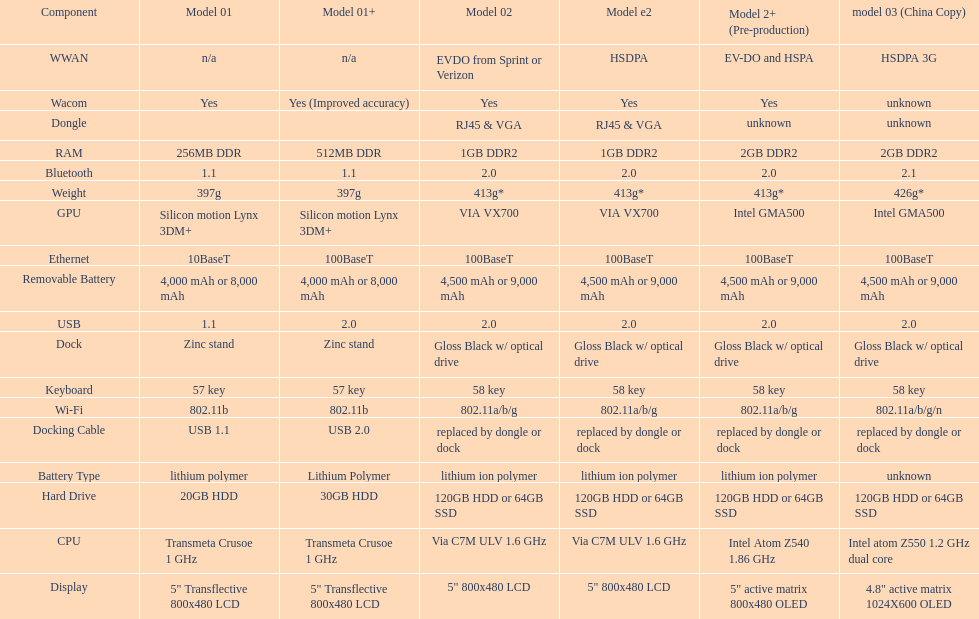How much more weight does the model 3 have over model 1? 29g. Can you give me this table as a dict? {'header': ['Component', 'Model 01', 'Model 01+', 'Model 02', 'Model e2', 'Model 2+ (Pre-production)', 'model 03 (China Copy)'], 'rows': [['WWAN', 'n/a', 'n/a', 'EVDO from Sprint or Verizon', 'HSDPA', 'EV-DO and HSPA', 'HSDPA 3G'], ['Wacom', 'Yes', 'Yes (Improved accuracy)', 'Yes', 'Yes', 'Yes', 'unknown'], ['Dongle', '', '', 'RJ45 & VGA', 'RJ45 & VGA', 'unknown', 'unknown'], ['RAM', '256MB DDR', '512MB DDR', '1GB DDR2', '1GB DDR2', '2GB DDR2', '2GB DDR2'], ['Bluetooth', '1.1', '1.1', '2.0', '2.0', '2.0', '2.1'], ['Weight', '397g', '397g', '413g*', '413g*', '413g*', '426g*'], ['GPU', 'Silicon motion Lynx 3DM+', 'Silicon motion Lynx 3DM+', 'VIA VX700', 'VIA VX700', 'Intel GMA500', 'Intel GMA500'], ['Ethernet', '10BaseT', '100BaseT', '100BaseT', '100BaseT', '100BaseT', '100BaseT'], ['Removable Battery', '4,000 mAh or 8,000 mAh', '4,000 mAh or 8,000 mAh', '4,500 mAh or 9,000 mAh', '4,500 mAh or 9,000 mAh', '4,500 mAh or 9,000 mAh', '4,500 mAh or 9,000 mAh'], ['USB', '1.1', '2.0', '2.0', '2.0', '2.0', '2.0'], ['Dock', 'Zinc stand', 'Zinc stand', 'Gloss Black w/ optical drive', 'Gloss Black w/ optical drive', 'Gloss Black w/ optical drive', 'Gloss Black w/ optical drive'], ['Keyboard', '57 key', '57 key', '58 key', '58 key', '58 key', '58 key'], ['Wi-Fi', '802.11b', '802.11b', '802.11a/b/g', '802.11a/b/g', '802.11a/b/g', '802.11a/b/g/n'], ['Docking Cable', 'USB 1.1', 'USB 2.0', 'replaced by dongle or dock', 'replaced by dongle or dock', 'replaced by dongle or dock', 'replaced by dongle or dock'], ['Battery Type', 'lithium polymer', 'Lithium Polymer', 'lithium ion polymer', 'lithium ion polymer', 'lithium ion polymer', 'unknown'], ['Hard Drive', '20GB HDD', '30GB HDD', '120GB HDD or 64GB SSD', '120GB HDD or 64GB SSD', '120GB HDD or 64GB SSD', '120GB HDD or 64GB SSD'], ['CPU', 'Transmeta Crusoe 1\xa0GHz', 'Transmeta Crusoe 1\xa0GHz', 'Via C7M ULV 1.6\xa0GHz', 'Via C7M ULV 1.6\xa0GHz', 'Intel Atom Z540 1.86\xa0GHz', 'Intel atom Z550 1.2\xa0GHz dual core'], ['Display', '5" Transflective 800x480 LCD', '5" Transflective 800x480 LCD', '5" 800x480 LCD', '5" 800x480 LCD', '5" active matrix 800x480 OLED', '4.8" active matrix 1024X600 OLED']]} 